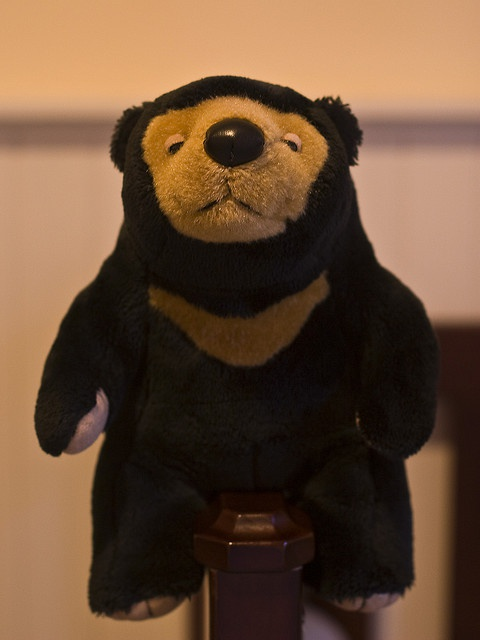Describe the objects in this image and their specific colors. I can see a teddy bear in tan, black, maroon, and olive tones in this image. 